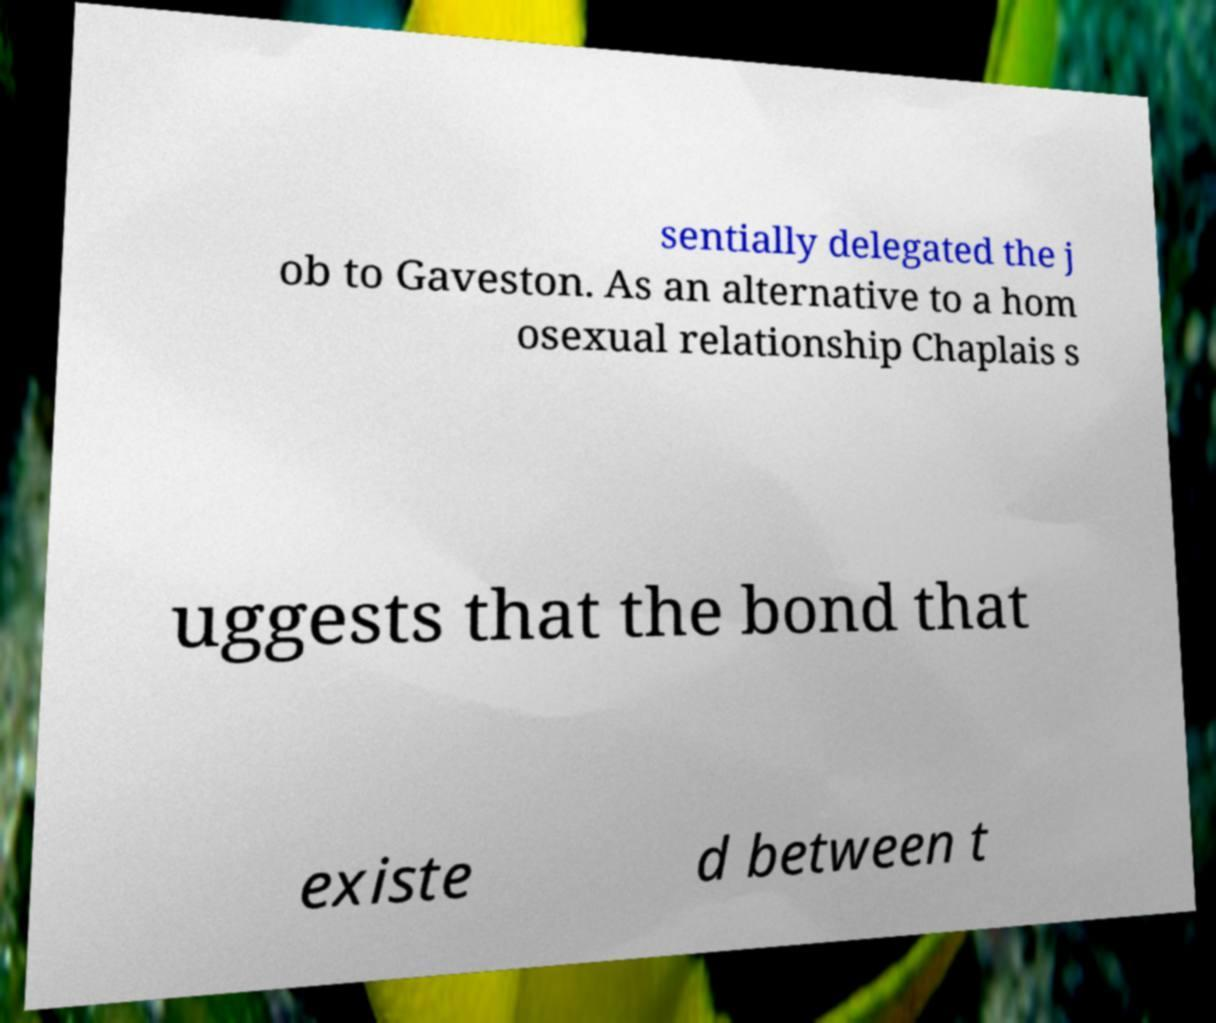Please read and relay the text visible in this image. What does it say? sentially delegated the j ob to Gaveston. As an alternative to a hom osexual relationship Chaplais s uggests that the bond that existe d between t 